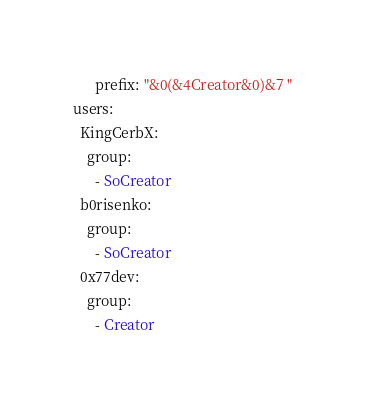<code> <loc_0><loc_0><loc_500><loc_500><_YAML_>      prefix: "&0(&4Creator&0)&7 "
users:
  KingCerbX:
    group:
      - SoCreator
  b0risenko:
    group:
      - SoCreator
  0x77dev:
    group:
      - Creator
</code> 